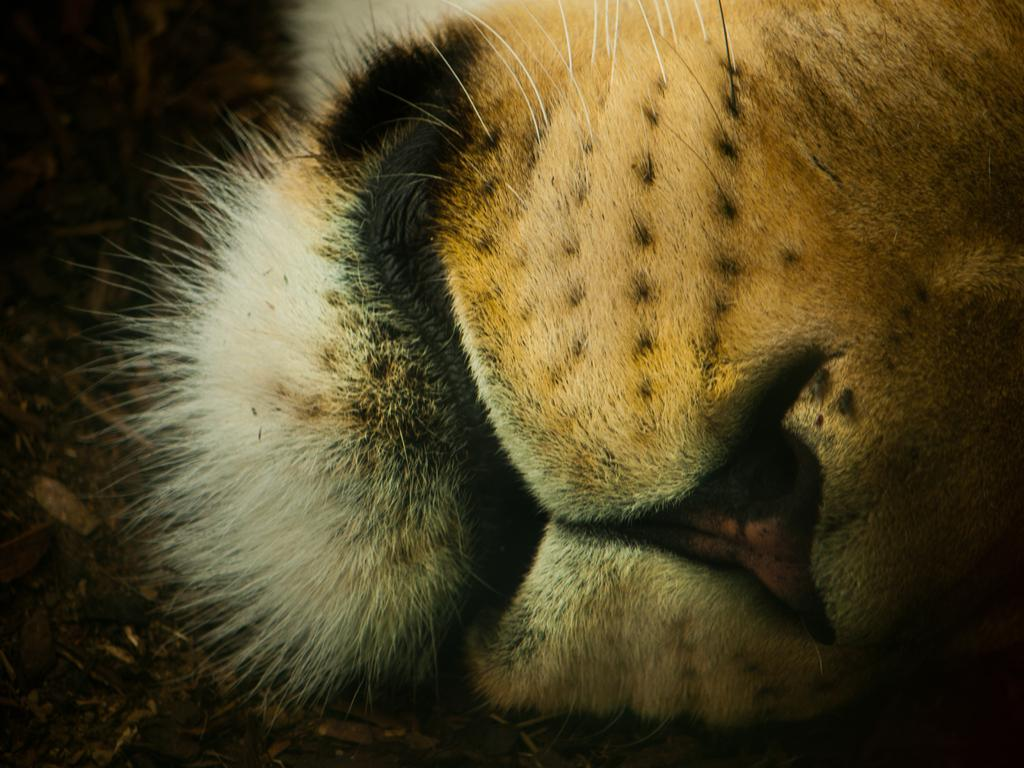What part of an animal can be seen in the image? There is an animal's mouth visible in the image. What type of poison is being administered by the arm in the image? There is no arm or poison present in the image; it only features an animal's mouth. 